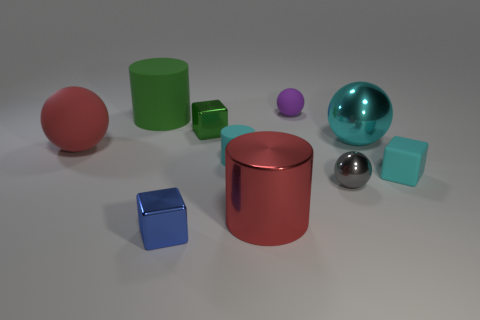What is the color of the largest sphere in the image? The color of the largest sphere in this image is cyan, which displays a shiny, metallic finish. 